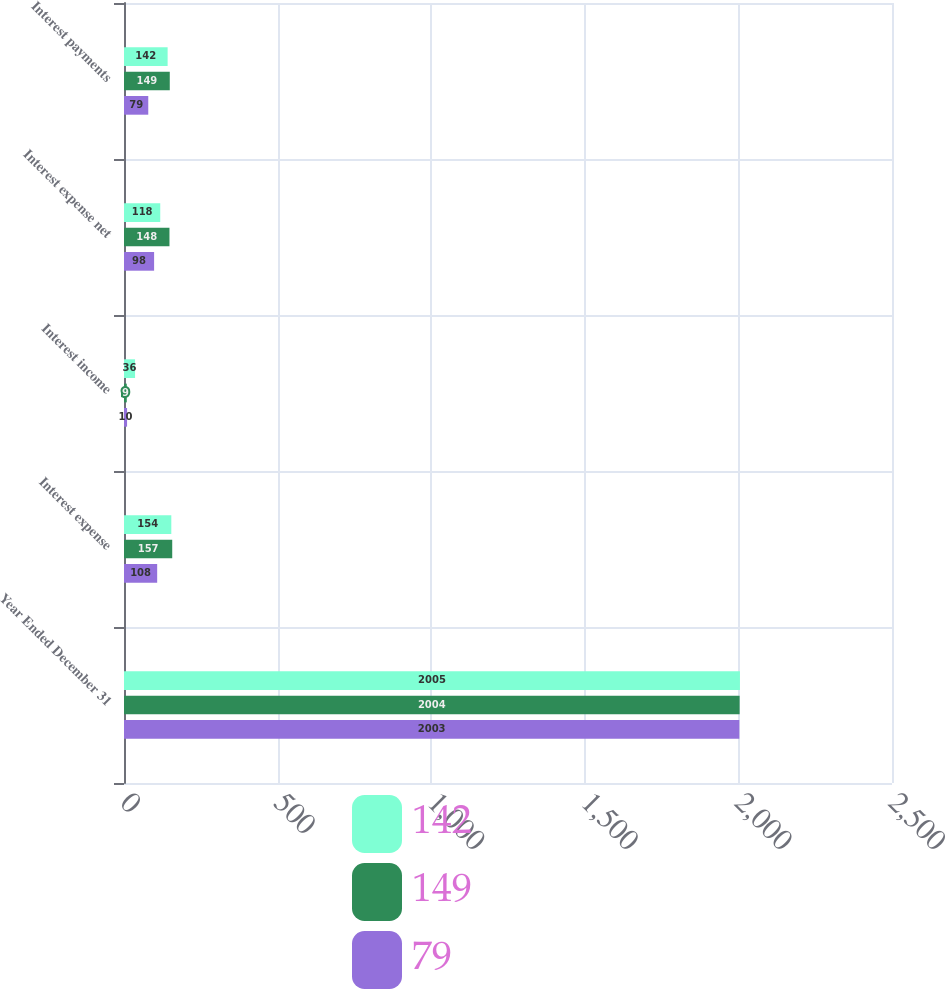Convert chart to OTSL. <chart><loc_0><loc_0><loc_500><loc_500><stacked_bar_chart><ecel><fcel>Year Ended December 31<fcel>Interest expense<fcel>Interest income<fcel>Interest expense net<fcel>Interest payments<nl><fcel>142<fcel>2005<fcel>154<fcel>36<fcel>118<fcel>142<nl><fcel>149<fcel>2004<fcel>157<fcel>9<fcel>148<fcel>149<nl><fcel>79<fcel>2003<fcel>108<fcel>10<fcel>98<fcel>79<nl></chart> 